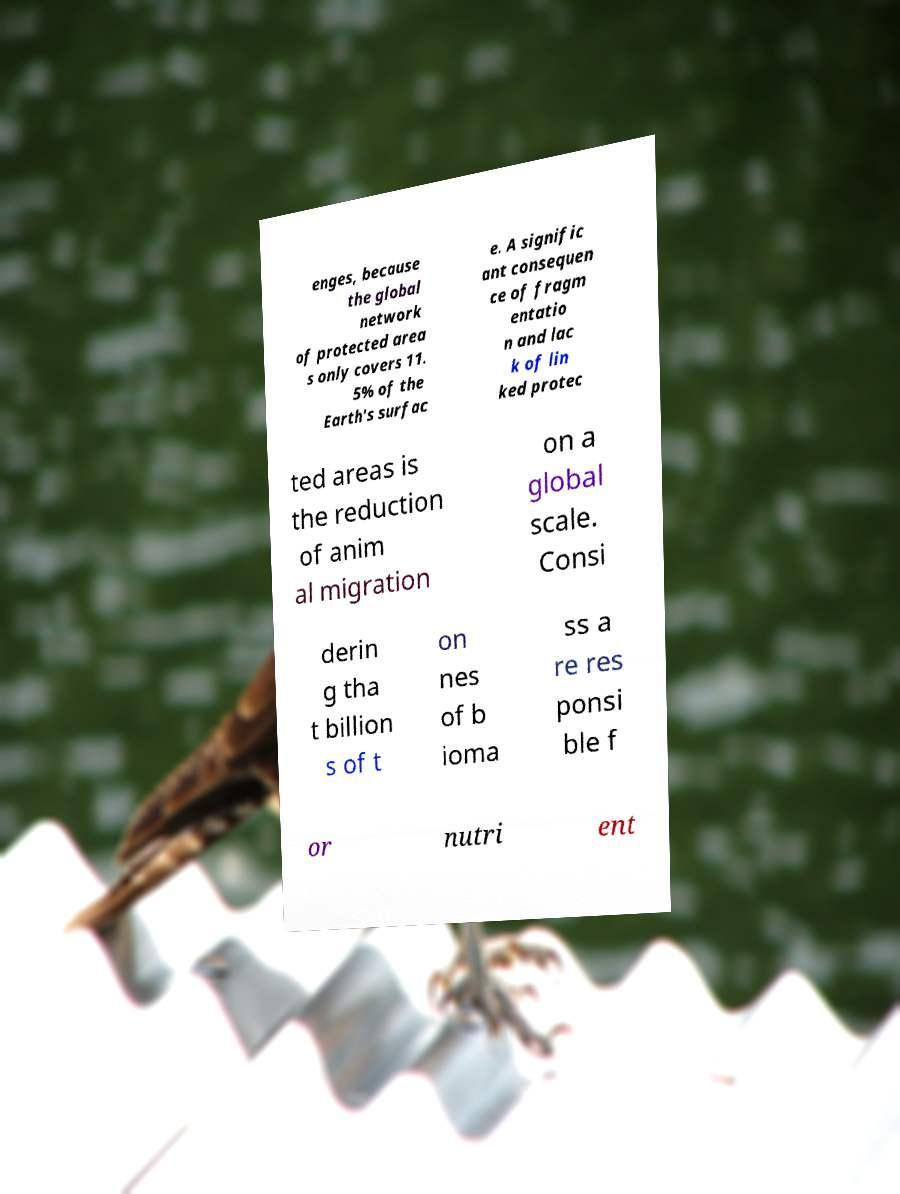Can you read and provide the text displayed in the image?This photo seems to have some interesting text. Can you extract and type it out for me? enges, because the global network of protected area s only covers 11. 5% of the Earth's surfac e. A signific ant consequen ce of fragm entatio n and lac k of lin ked protec ted areas is the reduction of anim al migration on a global scale. Consi derin g tha t billion s of t on nes of b ioma ss a re res ponsi ble f or nutri ent 